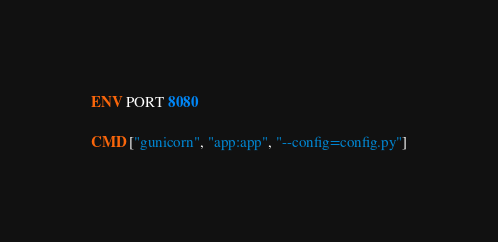Convert code to text. <code><loc_0><loc_0><loc_500><loc_500><_Dockerfile_>
ENV PORT 8080

CMD ["gunicorn", "app:app", "--config=config.py"]</code> 